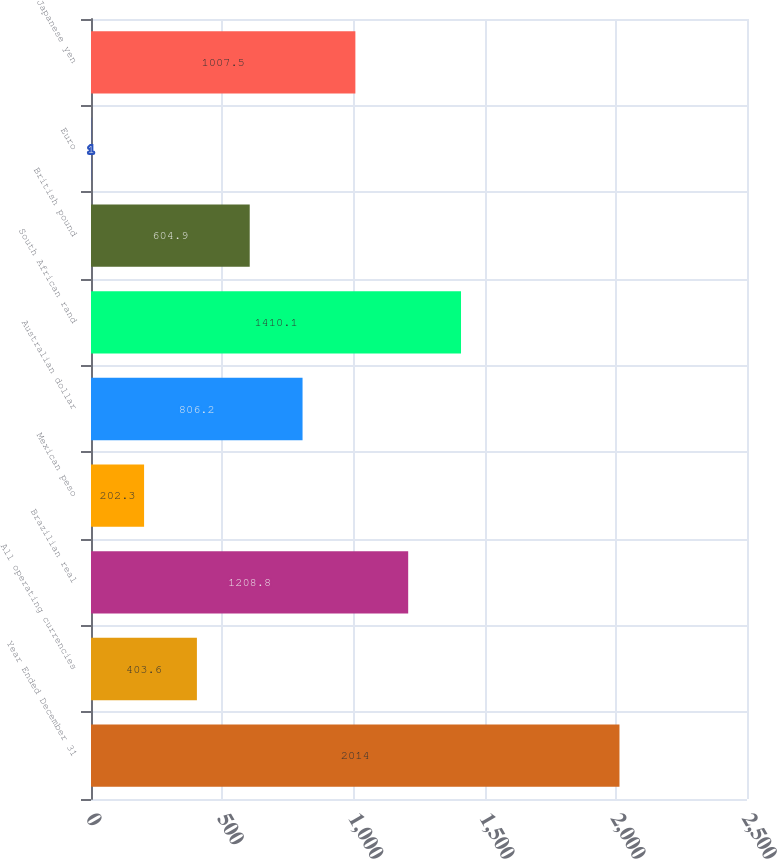<chart> <loc_0><loc_0><loc_500><loc_500><bar_chart><fcel>Year Ended December 31<fcel>All operating currencies<fcel>Brazilian real<fcel>Mexican peso<fcel>Australian dollar<fcel>South African rand<fcel>British pound<fcel>Euro<fcel>Japanese yen<nl><fcel>2014<fcel>403.6<fcel>1208.8<fcel>202.3<fcel>806.2<fcel>1410.1<fcel>604.9<fcel>1<fcel>1007.5<nl></chart> 